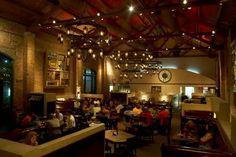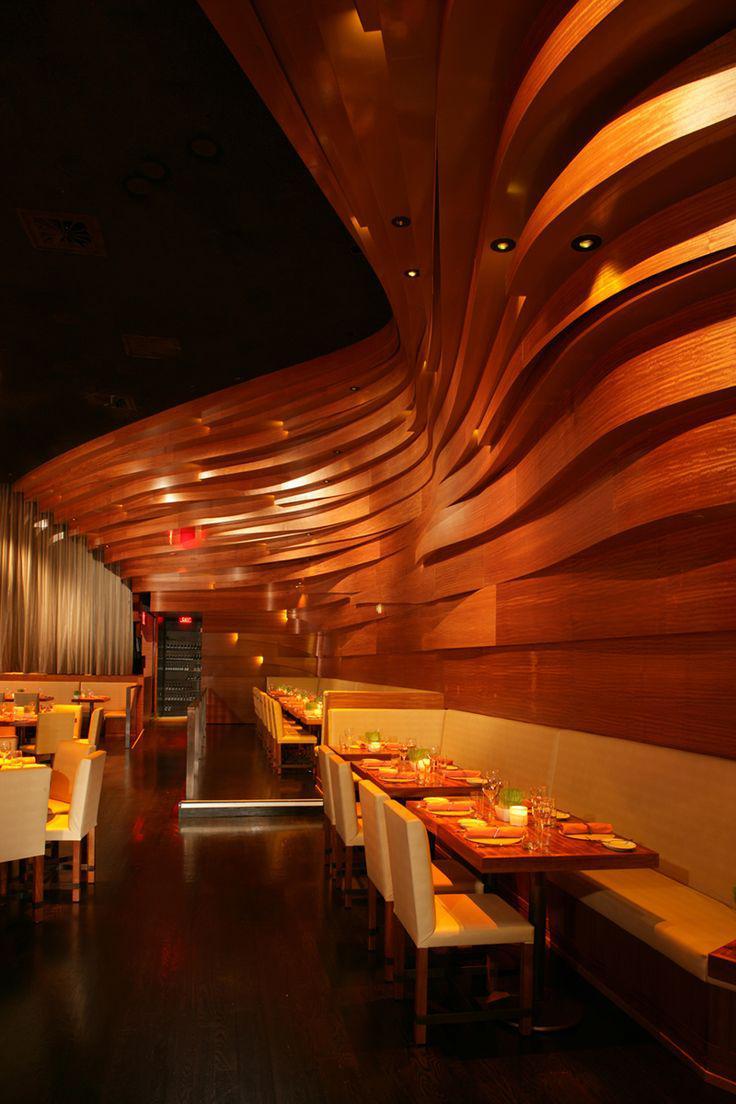The first image is the image on the left, the second image is the image on the right. Assess this claim about the two images: "The left image contains at least one chandelier.". Correct or not? Answer yes or no. Yes. The first image is the image on the left, the second image is the image on the right. Assess this claim about the two images: "The left image shows an interior with lights in a circle suspended from the ceiling, and the right image shows an interior with sculpted curving walls facing rows of seats.". Correct or not? Answer yes or no. Yes. 